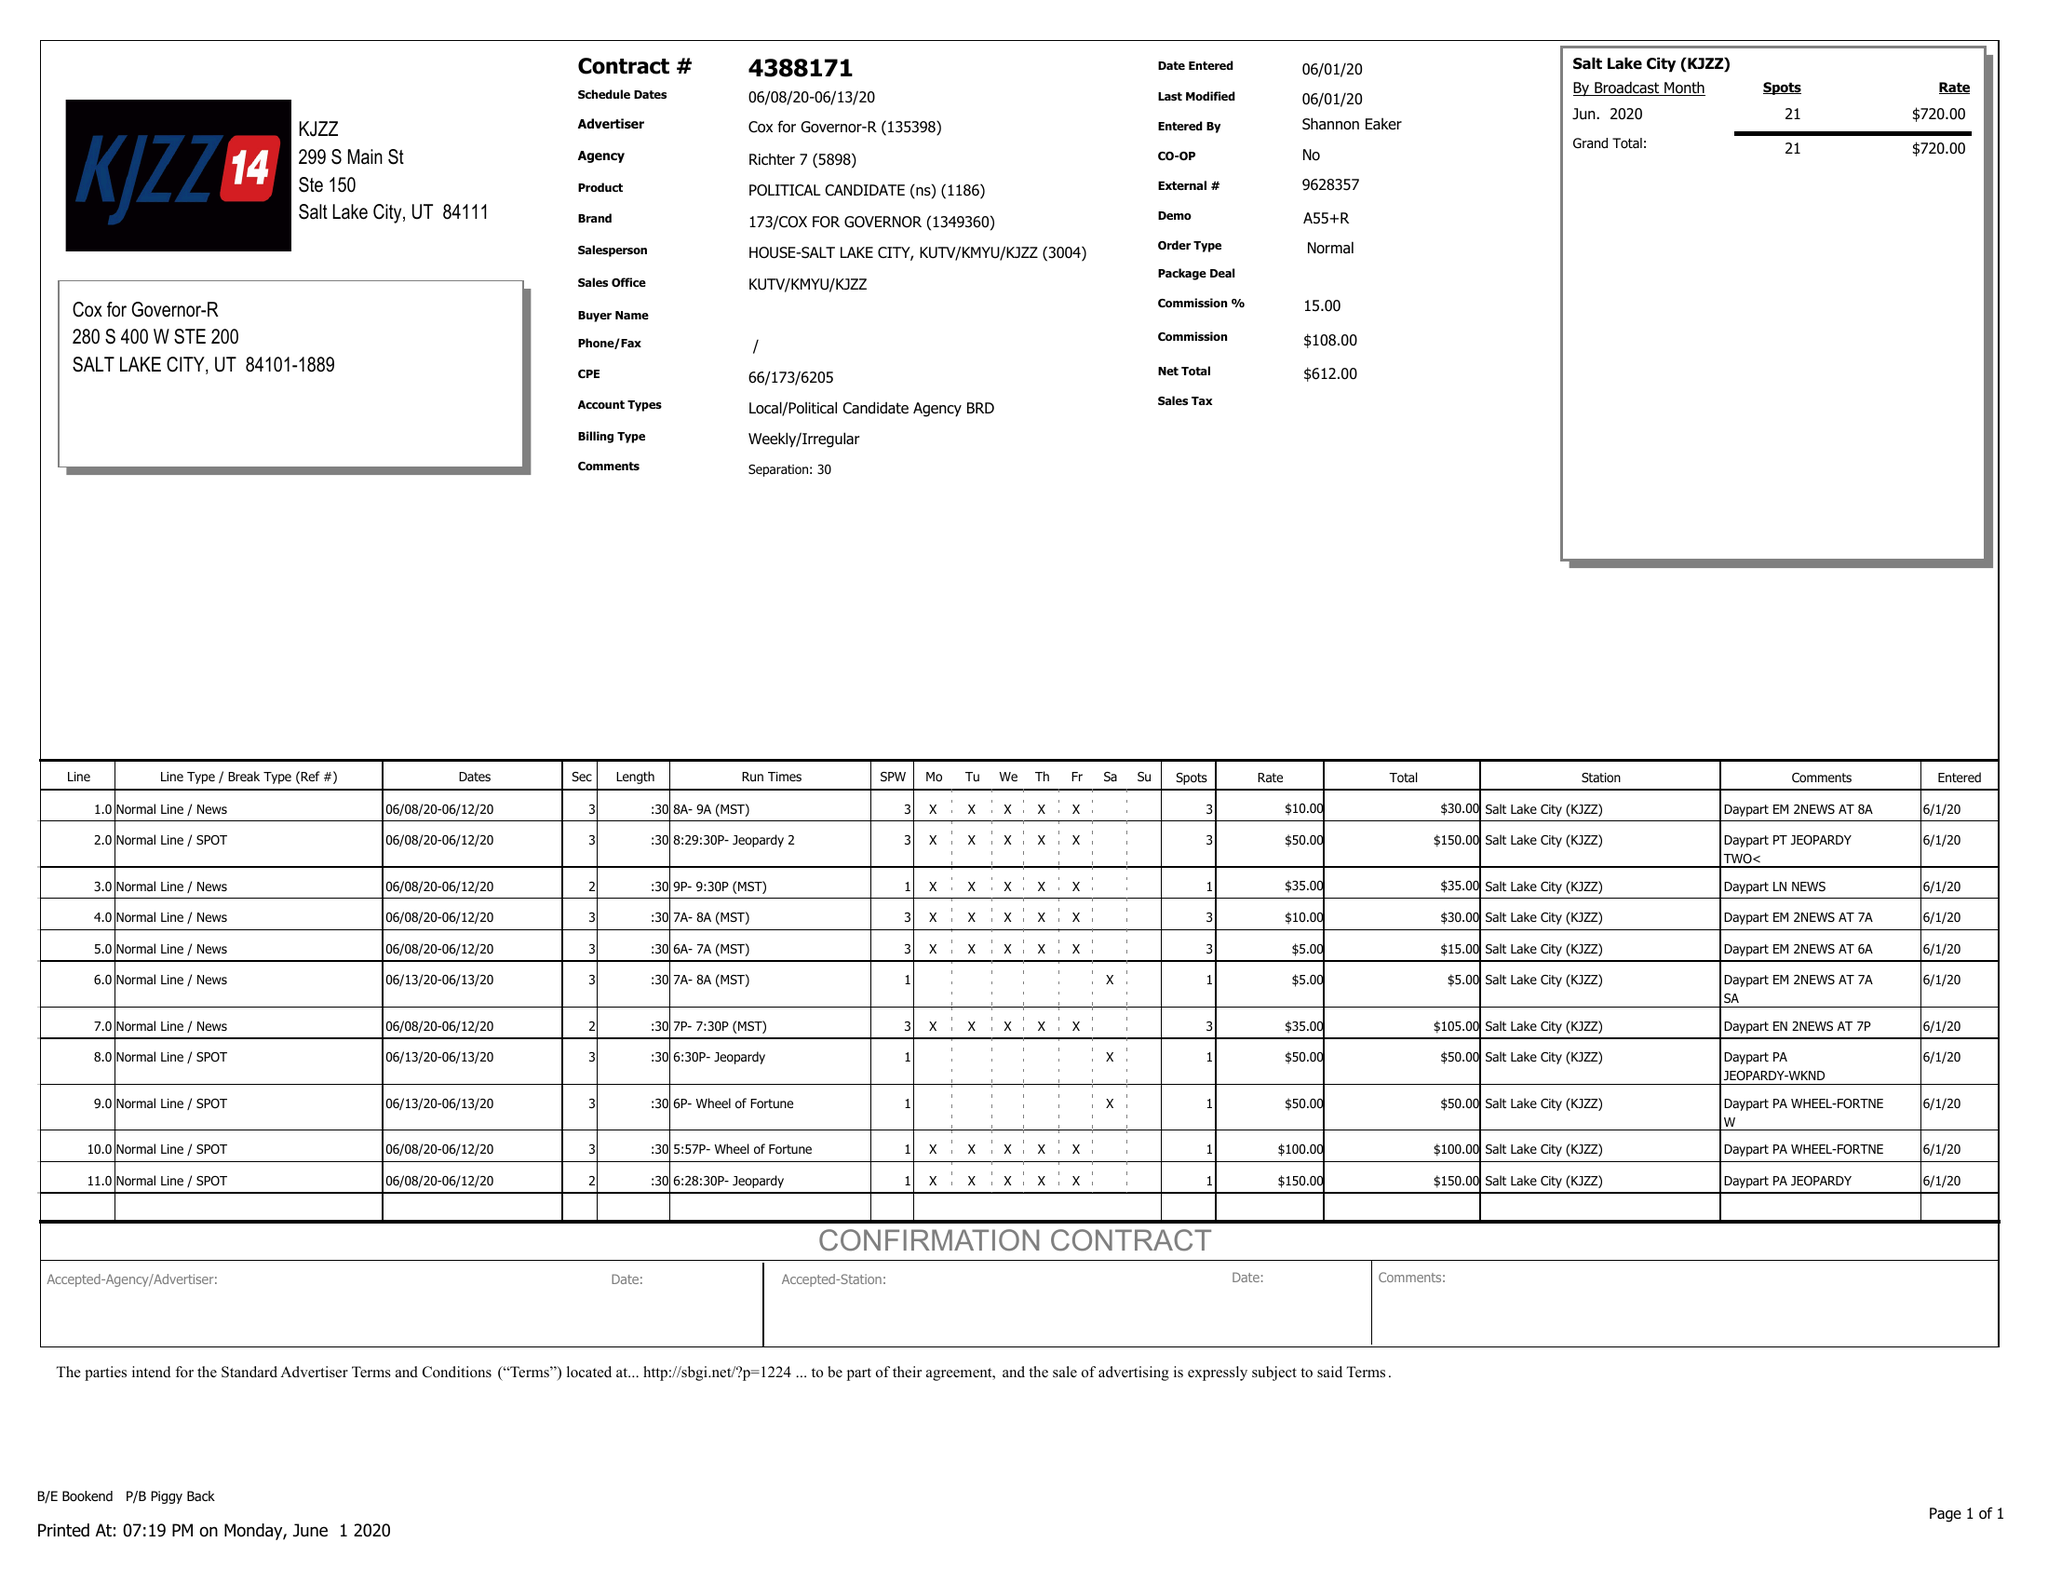What is the value for the gross_amount?
Answer the question using a single word or phrase. 720.00 